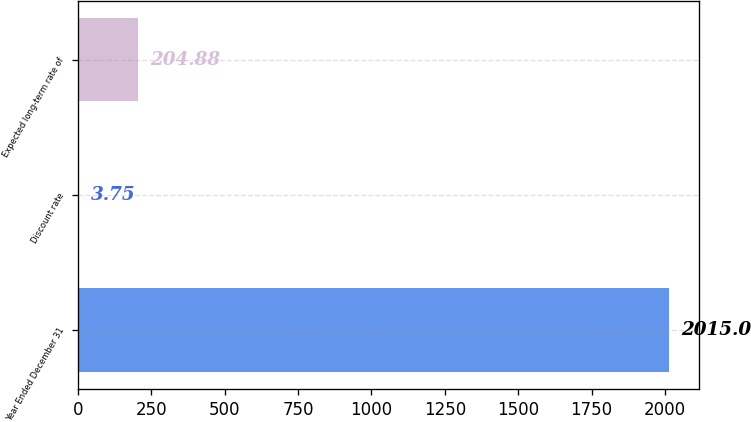Convert chart. <chart><loc_0><loc_0><loc_500><loc_500><bar_chart><fcel>Year Ended December 31<fcel>Discount rate<fcel>Expected long-term rate of<nl><fcel>2015<fcel>3.75<fcel>204.88<nl></chart> 